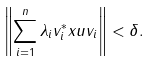Convert formula to latex. <formula><loc_0><loc_0><loc_500><loc_500>\left \| \sum _ { i = 1 } ^ { n } \lambda _ { i } v _ { i } ^ { * } x u v _ { i } \right \| < \delta .</formula> 